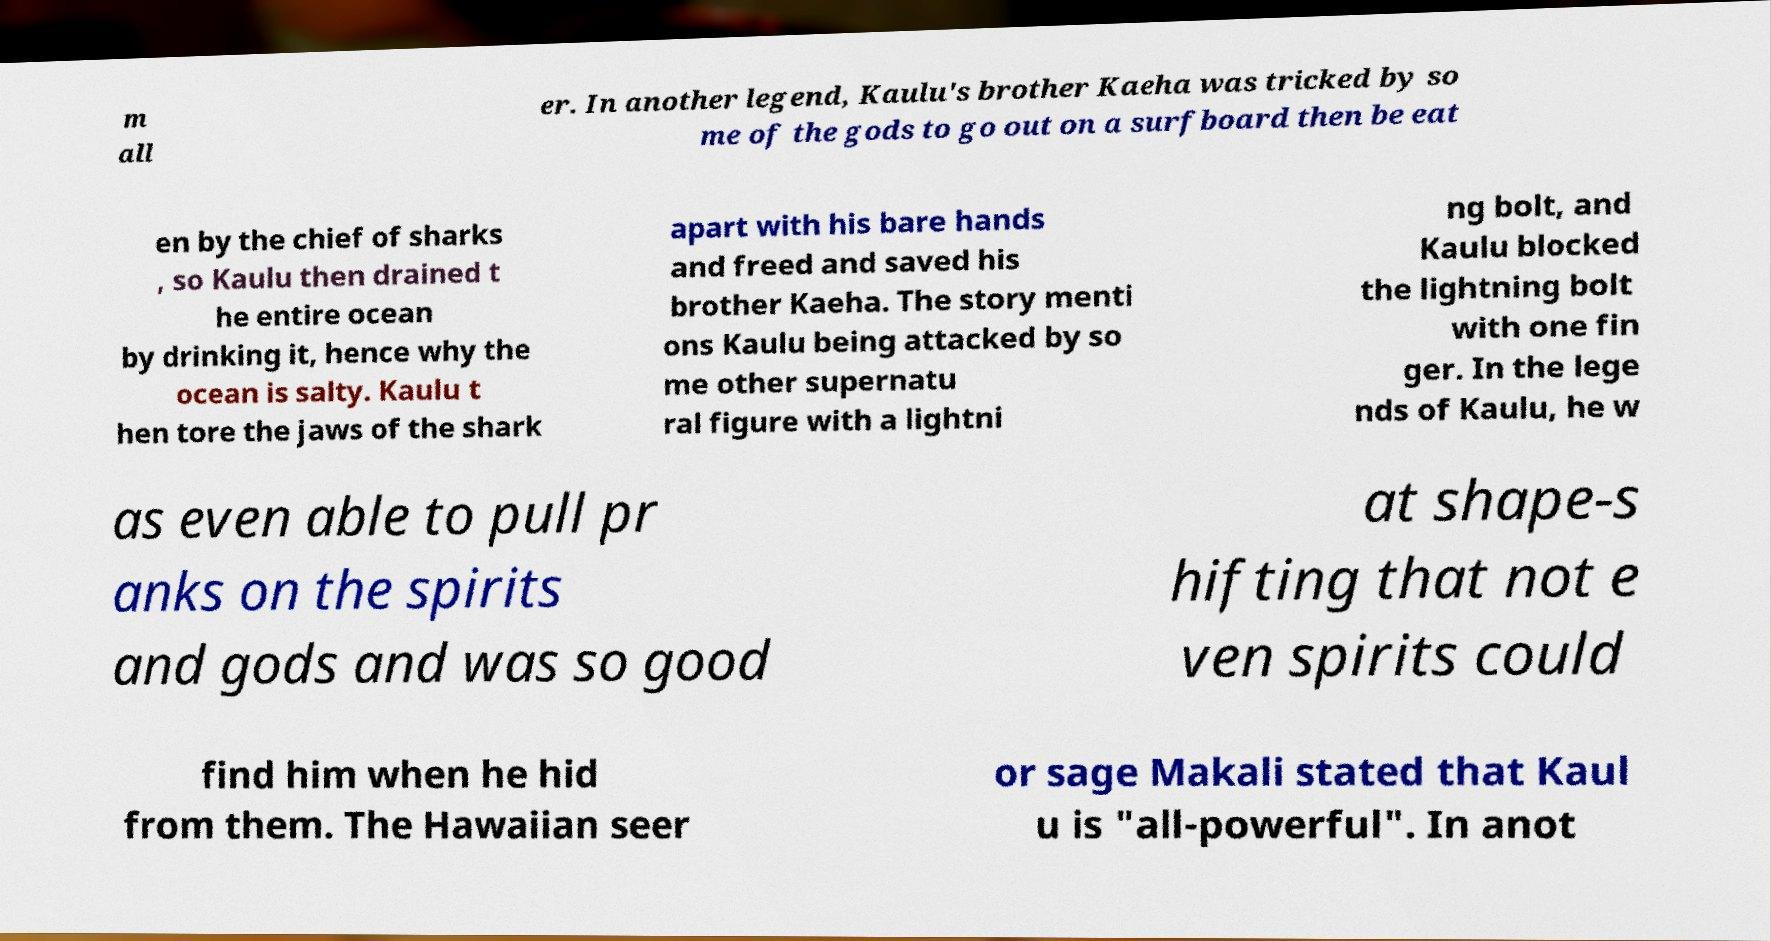Could you assist in decoding the text presented in this image and type it out clearly? m all er. In another legend, Kaulu's brother Kaeha was tricked by so me of the gods to go out on a surfboard then be eat en by the chief of sharks , so Kaulu then drained t he entire ocean by drinking it, hence why the ocean is salty. Kaulu t hen tore the jaws of the shark apart with his bare hands and freed and saved his brother Kaeha. The story menti ons Kaulu being attacked by so me other supernatu ral figure with a lightni ng bolt, and Kaulu blocked the lightning bolt with one fin ger. In the lege nds of Kaulu, he w as even able to pull pr anks on the spirits and gods and was so good at shape-s hifting that not e ven spirits could find him when he hid from them. The Hawaiian seer or sage Makali stated that Kaul u is "all-powerful". In anot 